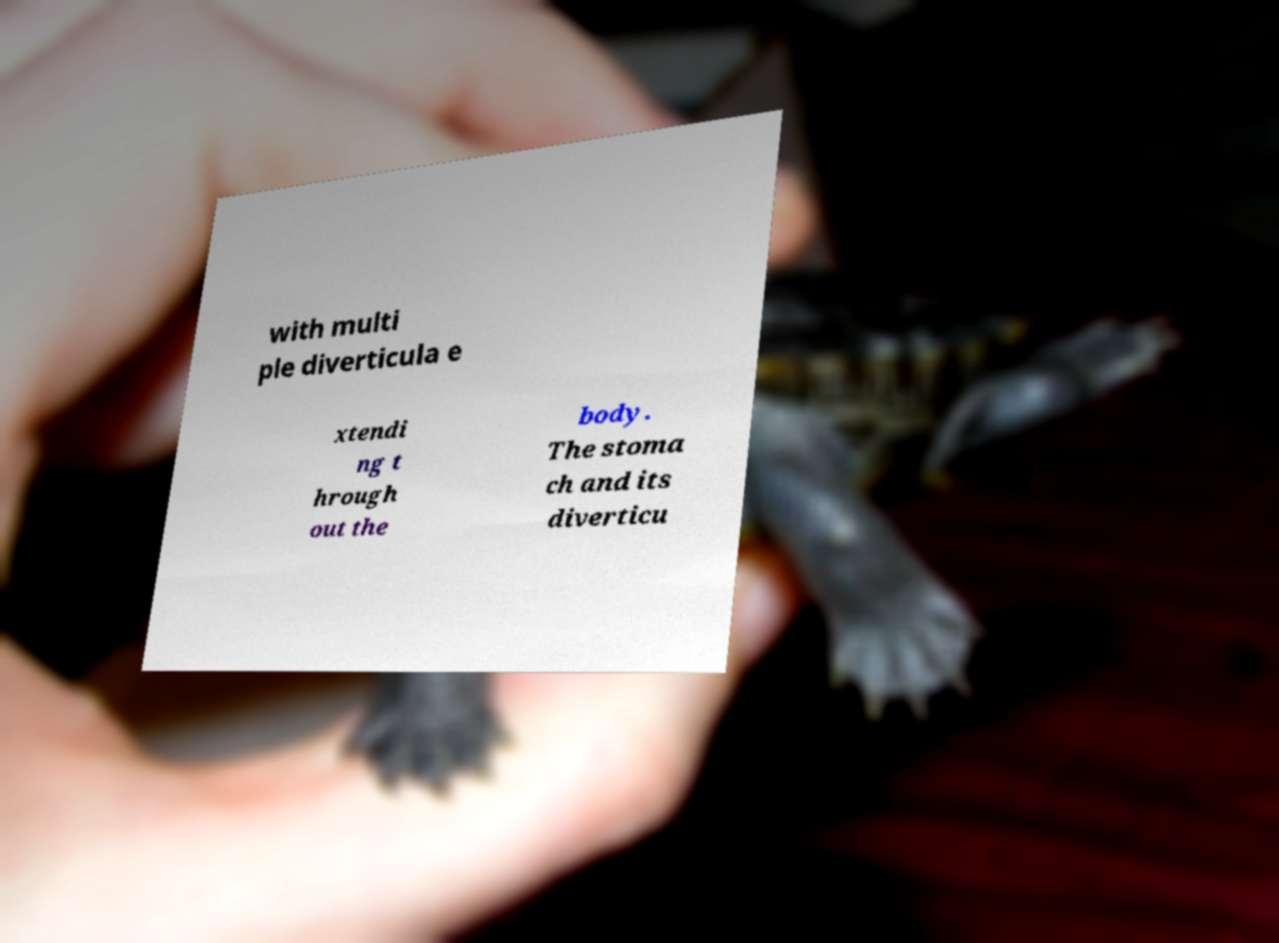Could you extract and type out the text from this image? with multi ple diverticula e xtendi ng t hrough out the body. The stoma ch and its diverticu 